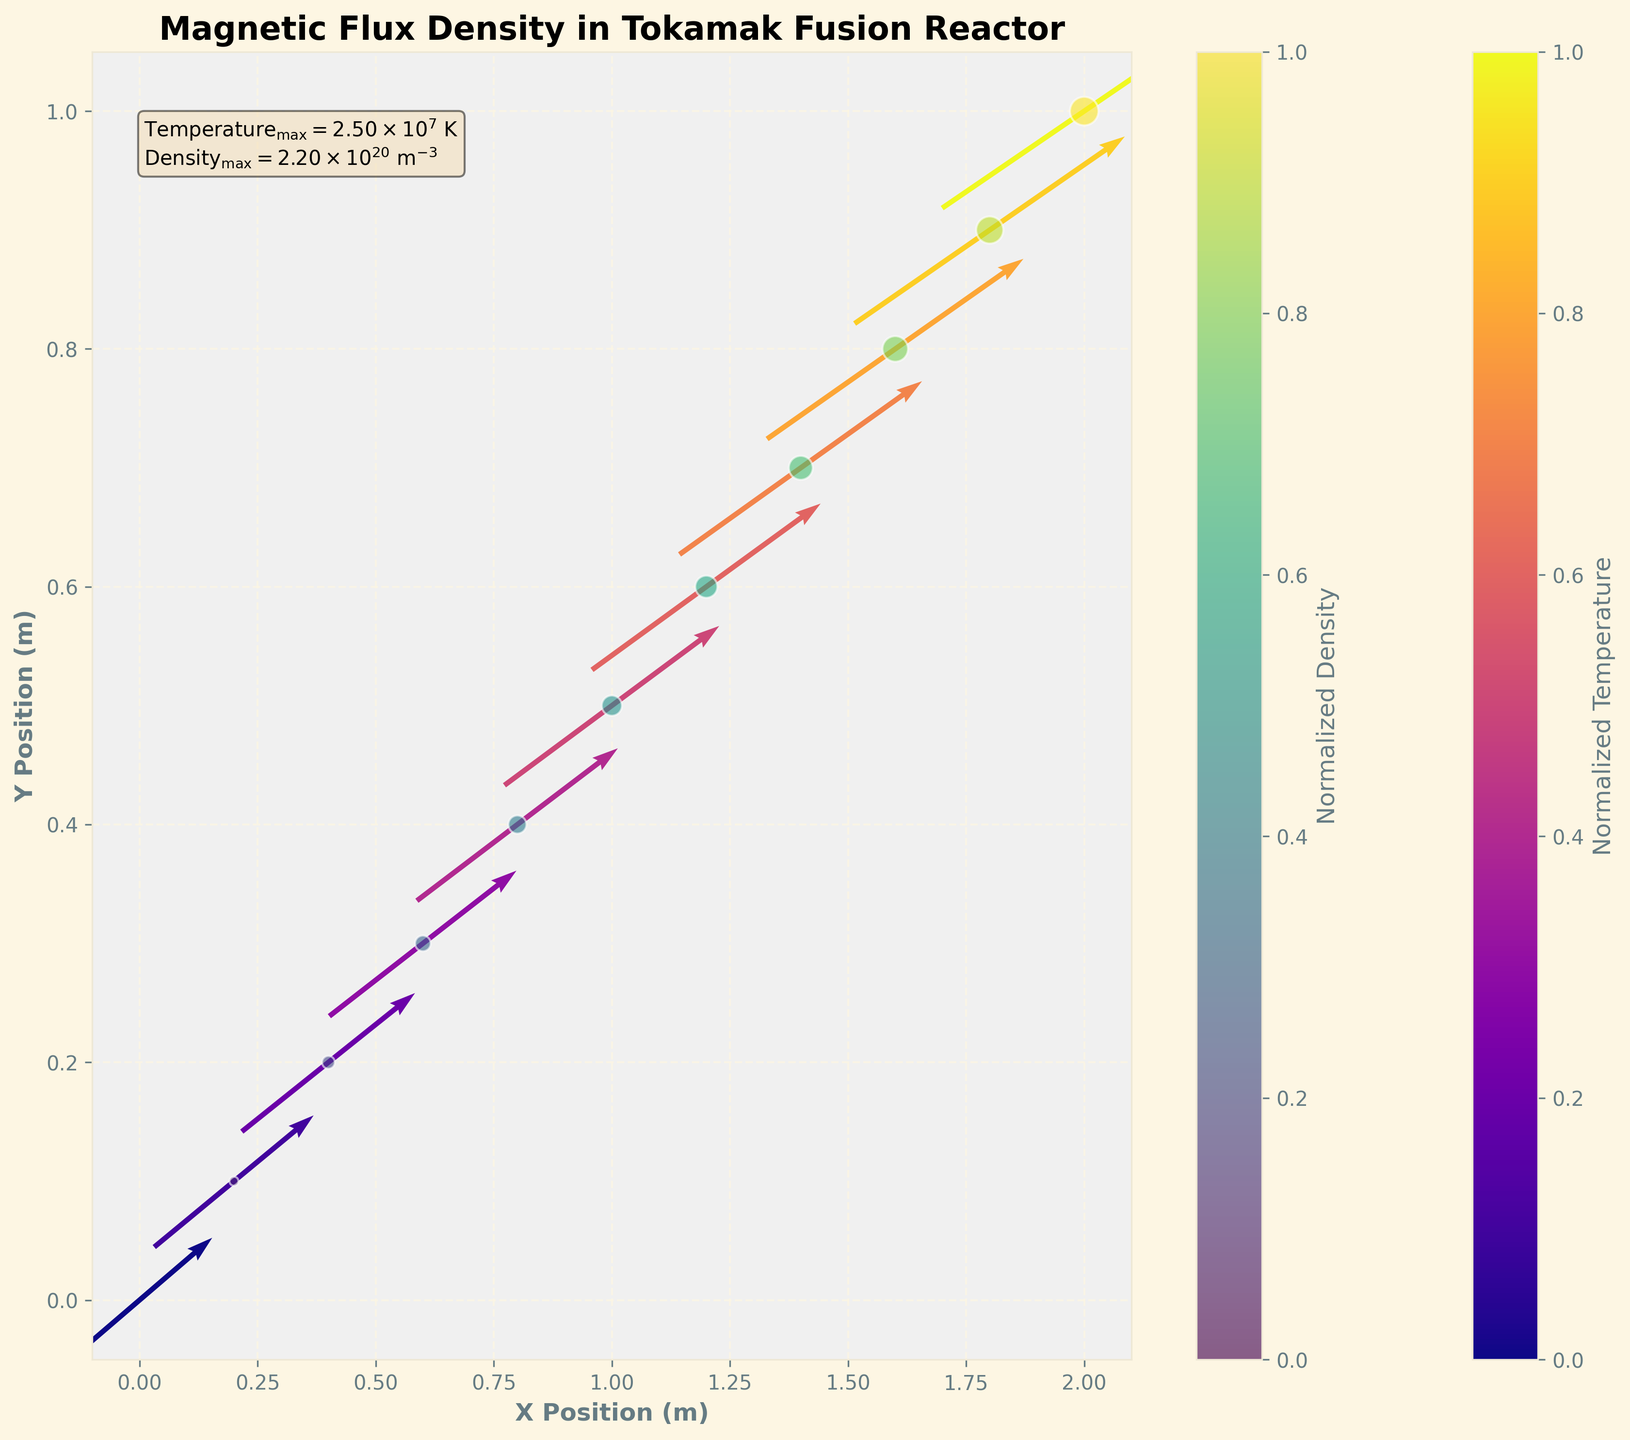What is the title of the figure? The title of the figure is located at the top center and reads, "Magnetic Flux Density in Tokamak Fusion Reactor".
Answer: Magnetic Flux Density in Tokamak Fusion Reactor How many data points are shown in the scatter plot? Each scatter point represents a (x, y) position, and there are 11 distinct points shown on the plot.
Answer: 11 What is the color scheme representing the normalized temperature on the quiver plot? The quiver plot is color-coded using the 'plasma' colormap, which ranges from purple for lower temperatures to yellow for higher temperatures.
Answer: Plasma colormap Which axis represents the X Position? The X Position is represented on the horizontal axis as labeled by "X Position (m)". You can see the ticks ranging from about 0.0 to 2.0.
Answer: Horizontal axis What is the maximum temperature displayed in the plot? The text box on the plot shows the maximum temperature as 2.50×10^7 K.
Answer: 2.50×10^7 K What does the size of the scatter points represent? The size of the scatter points represents the normalized density, with larger points indicating higher density values.
Answer: Normalized density Is the density value higher towards the center or the edges of the plot? By observing that the scatter points towards the center are larger, we can infer that the normalized density is higher towards the center of the plot.
Answer: Center How does the magnetic flux density (represented by the quiver arrows) change from left to right? The magnitude of the magnetic flux density increases from left to right, as seen by the increasing size and color change of the arrows.
Answer: Increases Compare the temperature variation with density variation across the plot. Do they both show an increasing trend? Both temperature and density show an increasing trend from left to right, as evidenced by the color intensity and size of the scatter points, respectively.
Answer: Yes What do the color gradients in the scatter plot indicate? The scatter plot points are color-coded using the 'viridis' colormap, representing the normalized density, with colors ranging from blue (lower density) to yellow (higher density).
Answer: Normalized density 